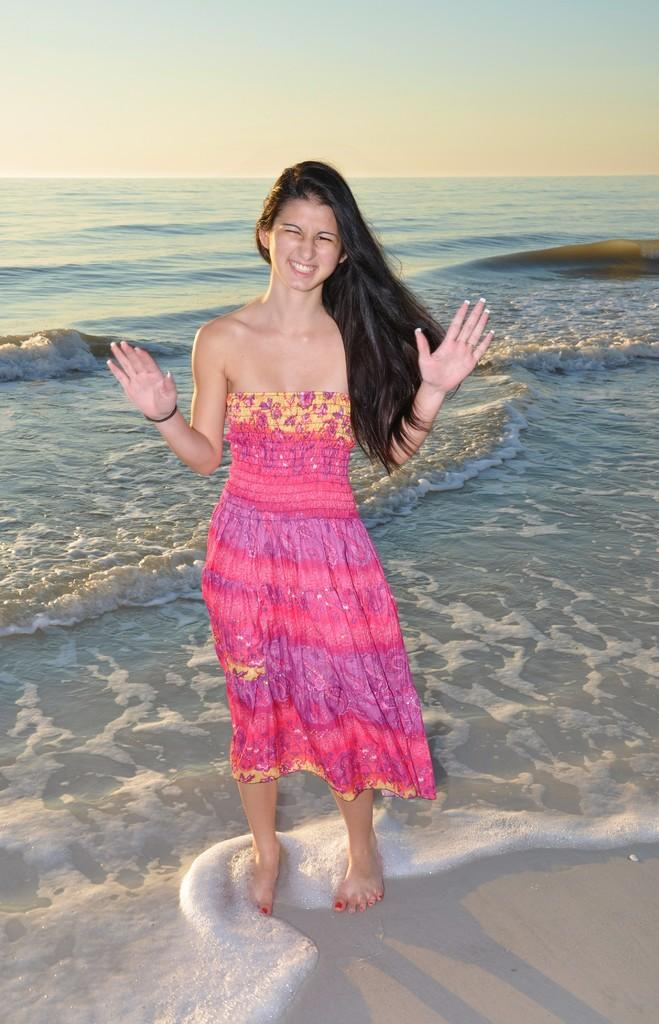Who is present in the image? There is a woman in the image. What is the woman doing in the image? The woman is standing in the image. What is the woman's facial expression in the image? The woman is smiling in the image. What can be seen in the background of the image? There is water in the background of the image. What is visible at the top of the image? The sky is visible at the top of the image. How many rabbits can be seen playing in the water in the image? There are no rabbits present in the image, and therefore no such activity can be observed. 